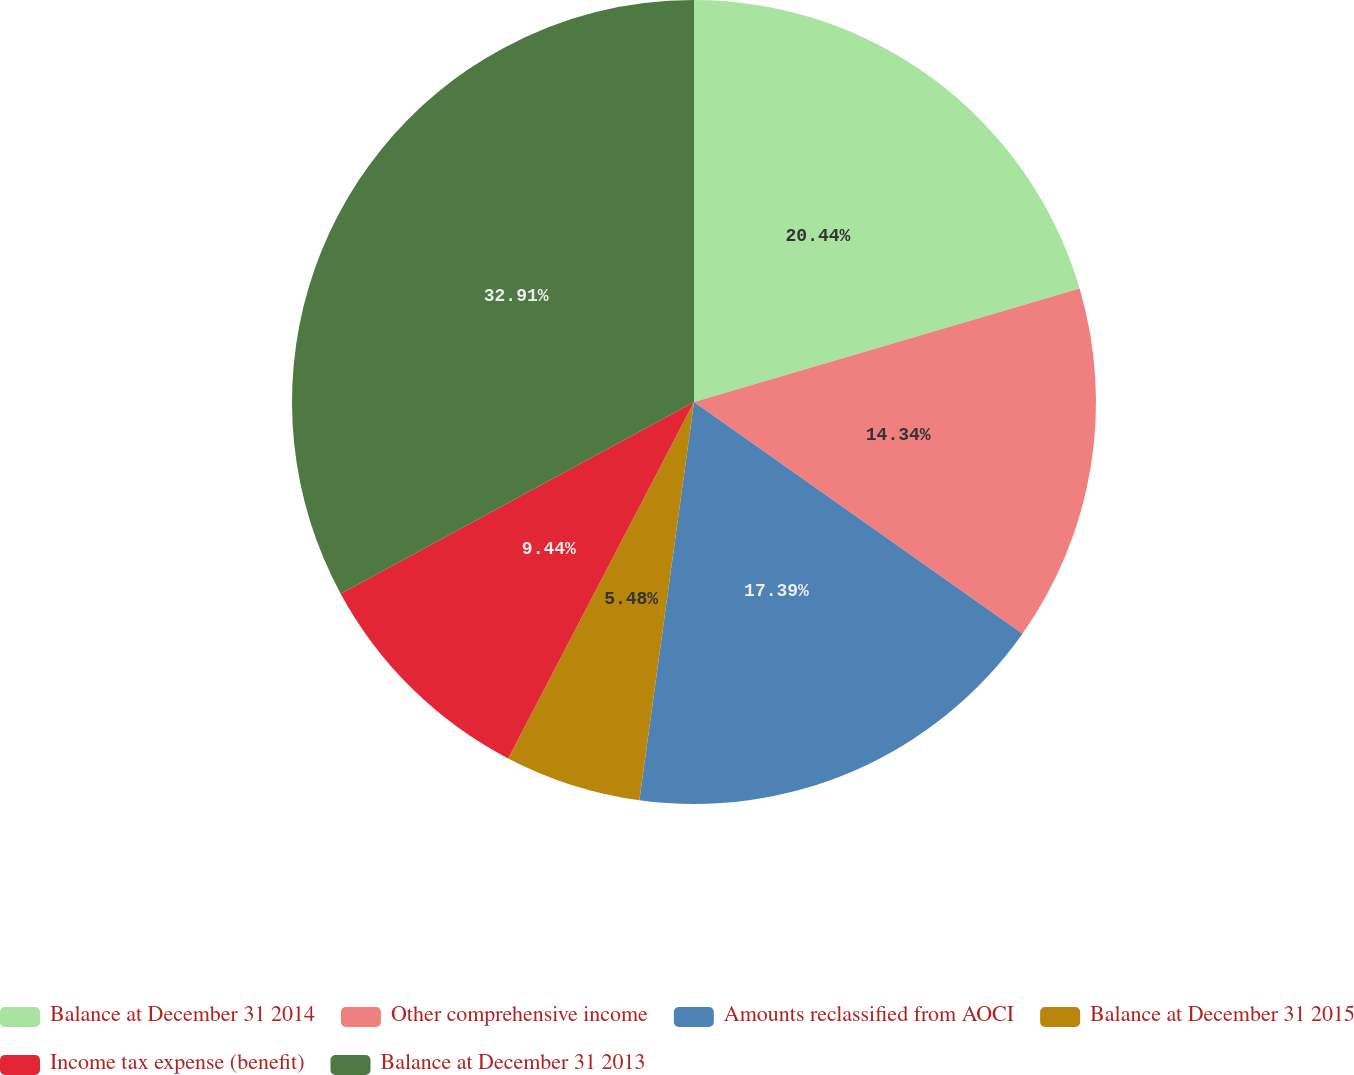Convert chart. <chart><loc_0><loc_0><loc_500><loc_500><pie_chart><fcel>Balance at December 31 2014<fcel>Other comprehensive income<fcel>Amounts reclassified from AOCI<fcel>Balance at December 31 2015<fcel>Income tax expense (benefit)<fcel>Balance at December 31 2013<nl><fcel>20.44%<fcel>14.34%<fcel>17.39%<fcel>5.48%<fcel>9.44%<fcel>32.91%<nl></chart> 